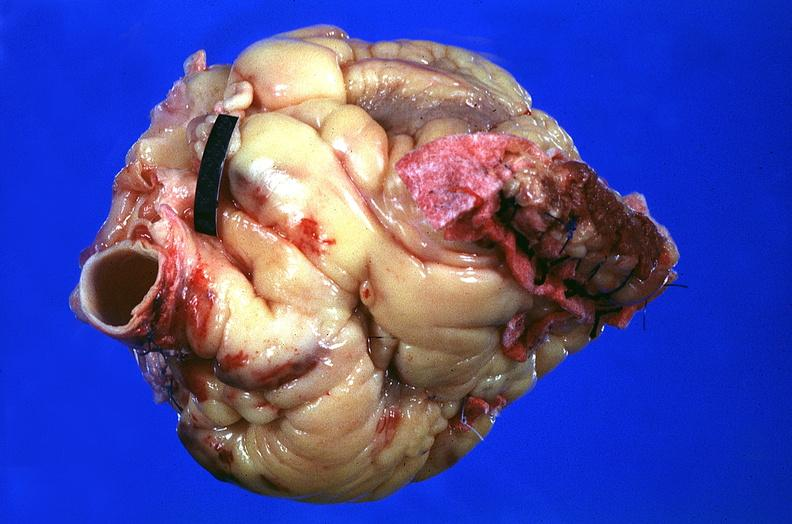what is present?
Answer the question using a single word or phrase. Cardiovascular 